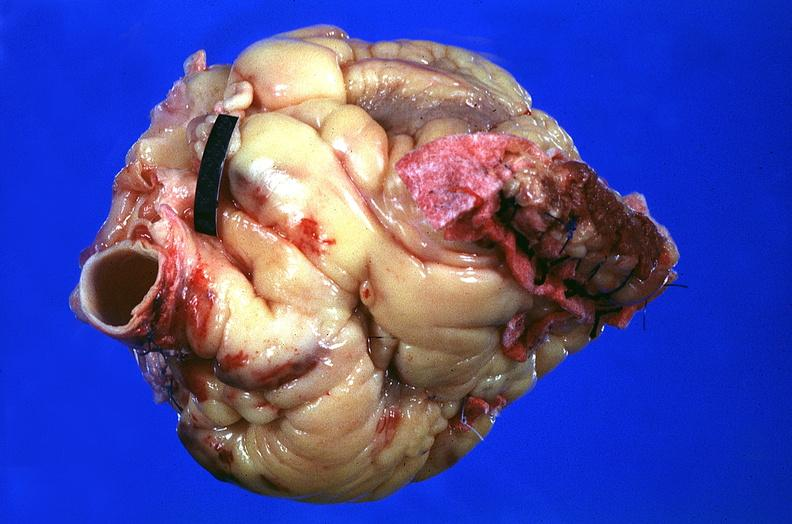what is present?
Answer the question using a single word or phrase. Cardiovascular 